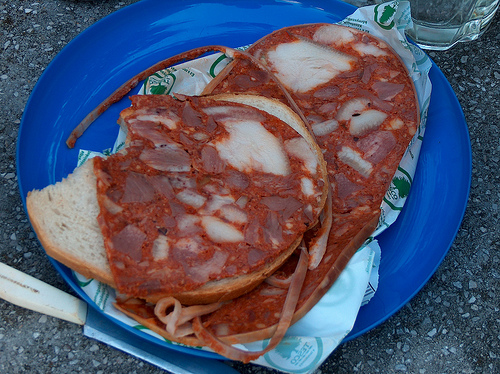<image>
Is the sauce on the bread? Yes. Looking at the image, I can see the sauce is positioned on top of the bread, with the bread providing support. 